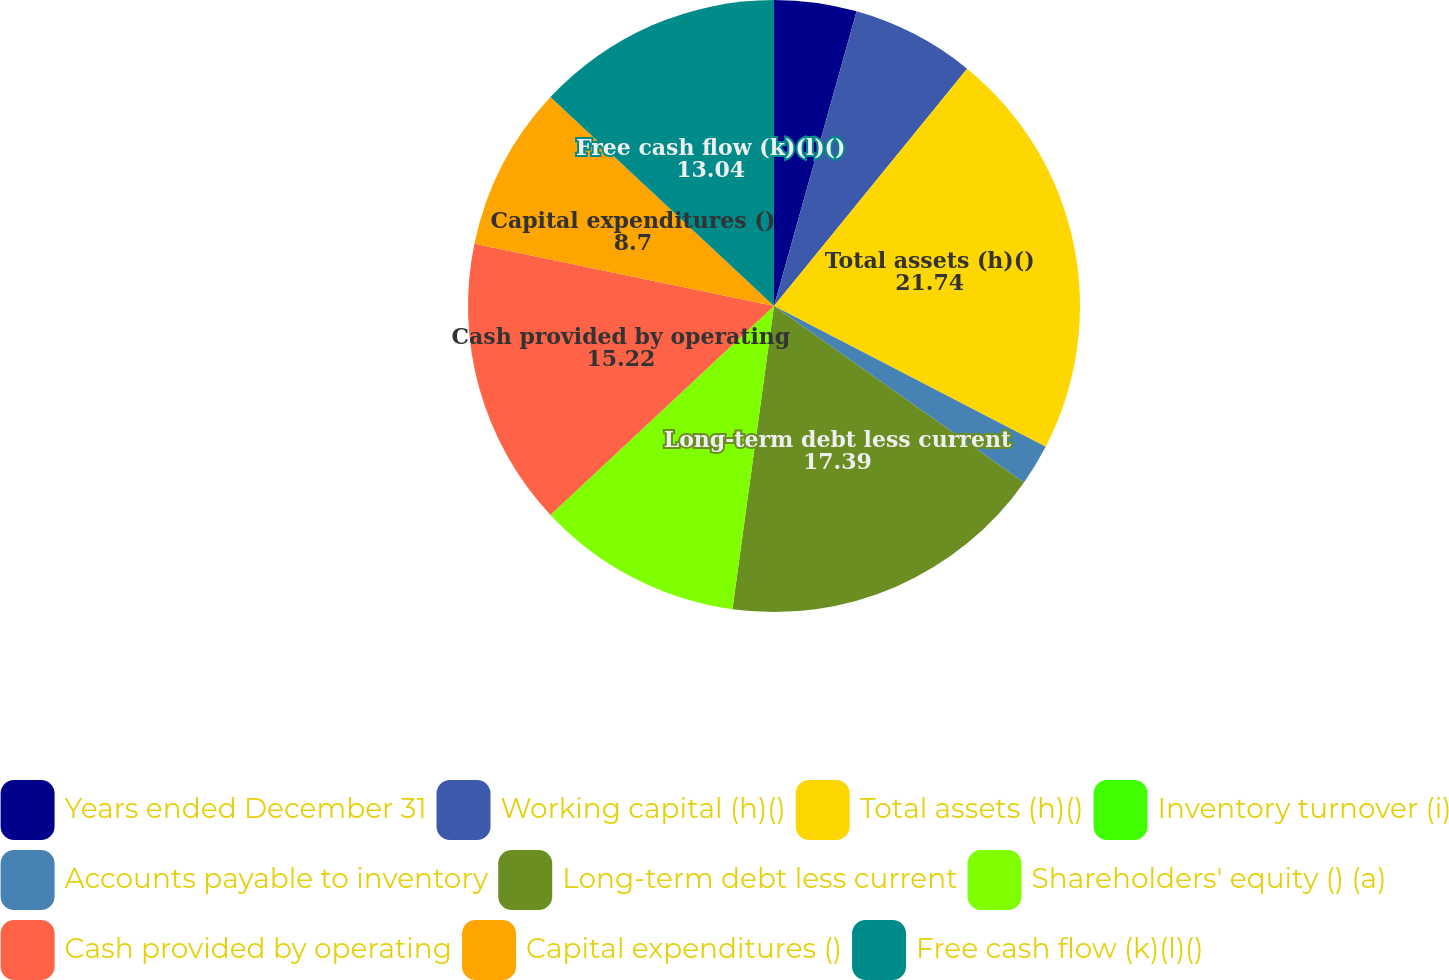Convert chart. <chart><loc_0><loc_0><loc_500><loc_500><pie_chart><fcel>Years ended December 31<fcel>Working capital (h)()<fcel>Total assets (h)()<fcel>Inventory turnover (i)<fcel>Accounts payable to inventory<fcel>Long-term debt less current<fcel>Shareholders' equity () (a)<fcel>Cash provided by operating<fcel>Capital expenditures ()<fcel>Free cash flow (k)(l)()<nl><fcel>4.35%<fcel>6.52%<fcel>21.74%<fcel>0.0%<fcel>2.17%<fcel>17.39%<fcel>10.87%<fcel>15.22%<fcel>8.7%<fcel>13.04%<nl></chart> 